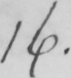What is written in this line of handwriting? 16 . 